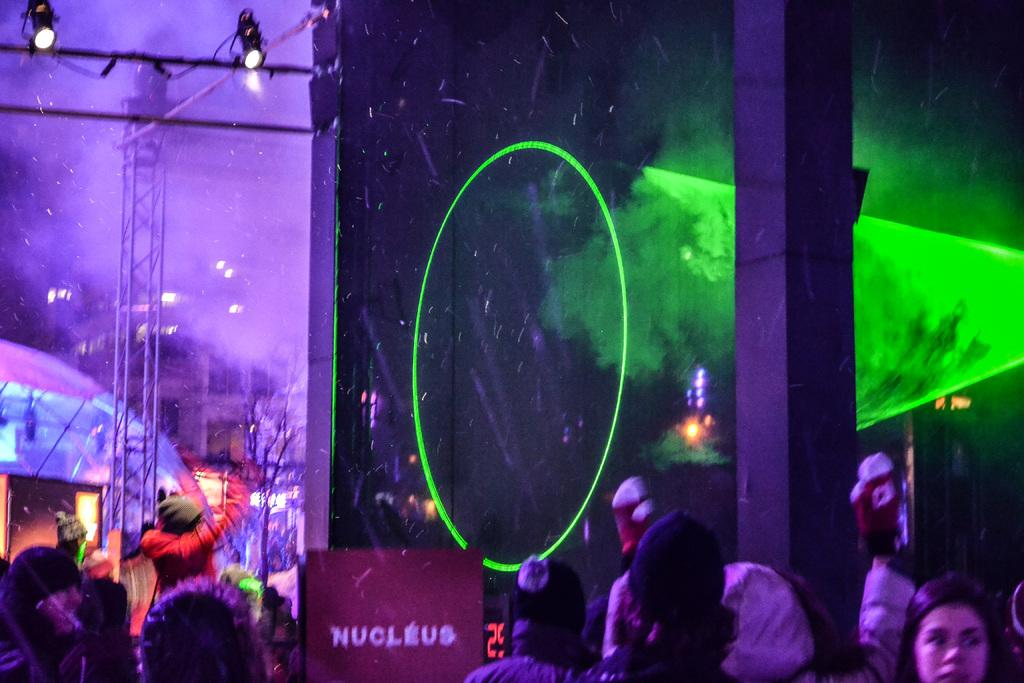How many people are in the image? There are people in the image, but the exact number is not specified. What are some people wearing on their heads? Some people are wearing caps in the image. What structures can be seen in the background of the image? In the background of the image, there is a pole, a pillar, a stand, lights, tents, a building, and rods. What type of shoes are the people wearing in the image? There is no information about shoes in the image, so we cannot determine what type of shoes the people are wearing. How does the pet interact with the pole in the background of the image? There is no pet present in the image, so we cannot describe any interaction with the pole. 